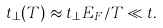<formula> <loc_0><loc_0><loc_500><loc_500>t _ { \perp } ( T ) \approx t _ { \perp } E _ { F } / T \ll t .</formula> 